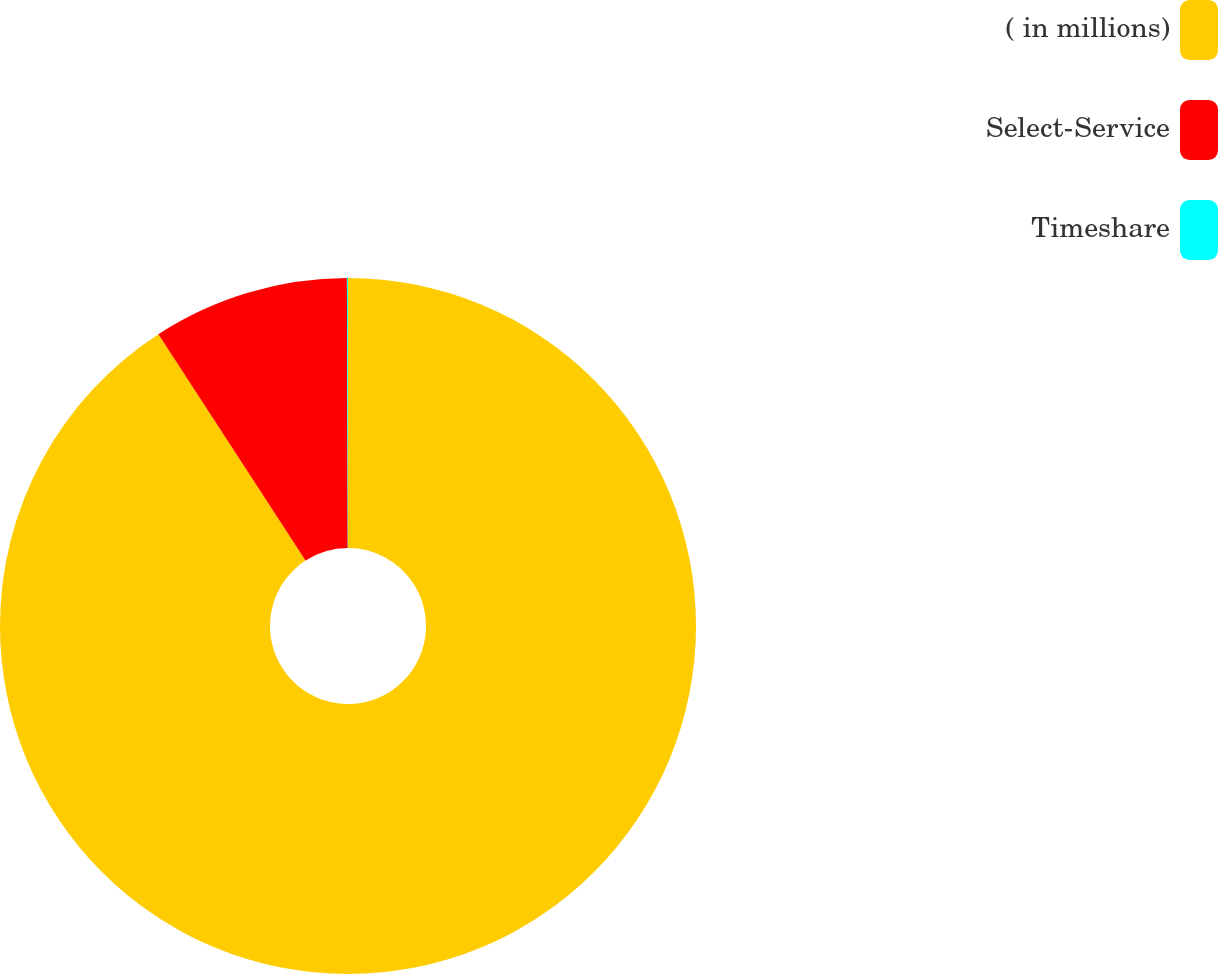<chart> <loc_0><loc_0><loc_500><loc_500><pie_chart><fcel>( in millions)<fcel>Select-Service<fcel>Timeshare<nl><fcel>90.83%<fcel>9.12%<fcel>0.05%<nl></chart> 